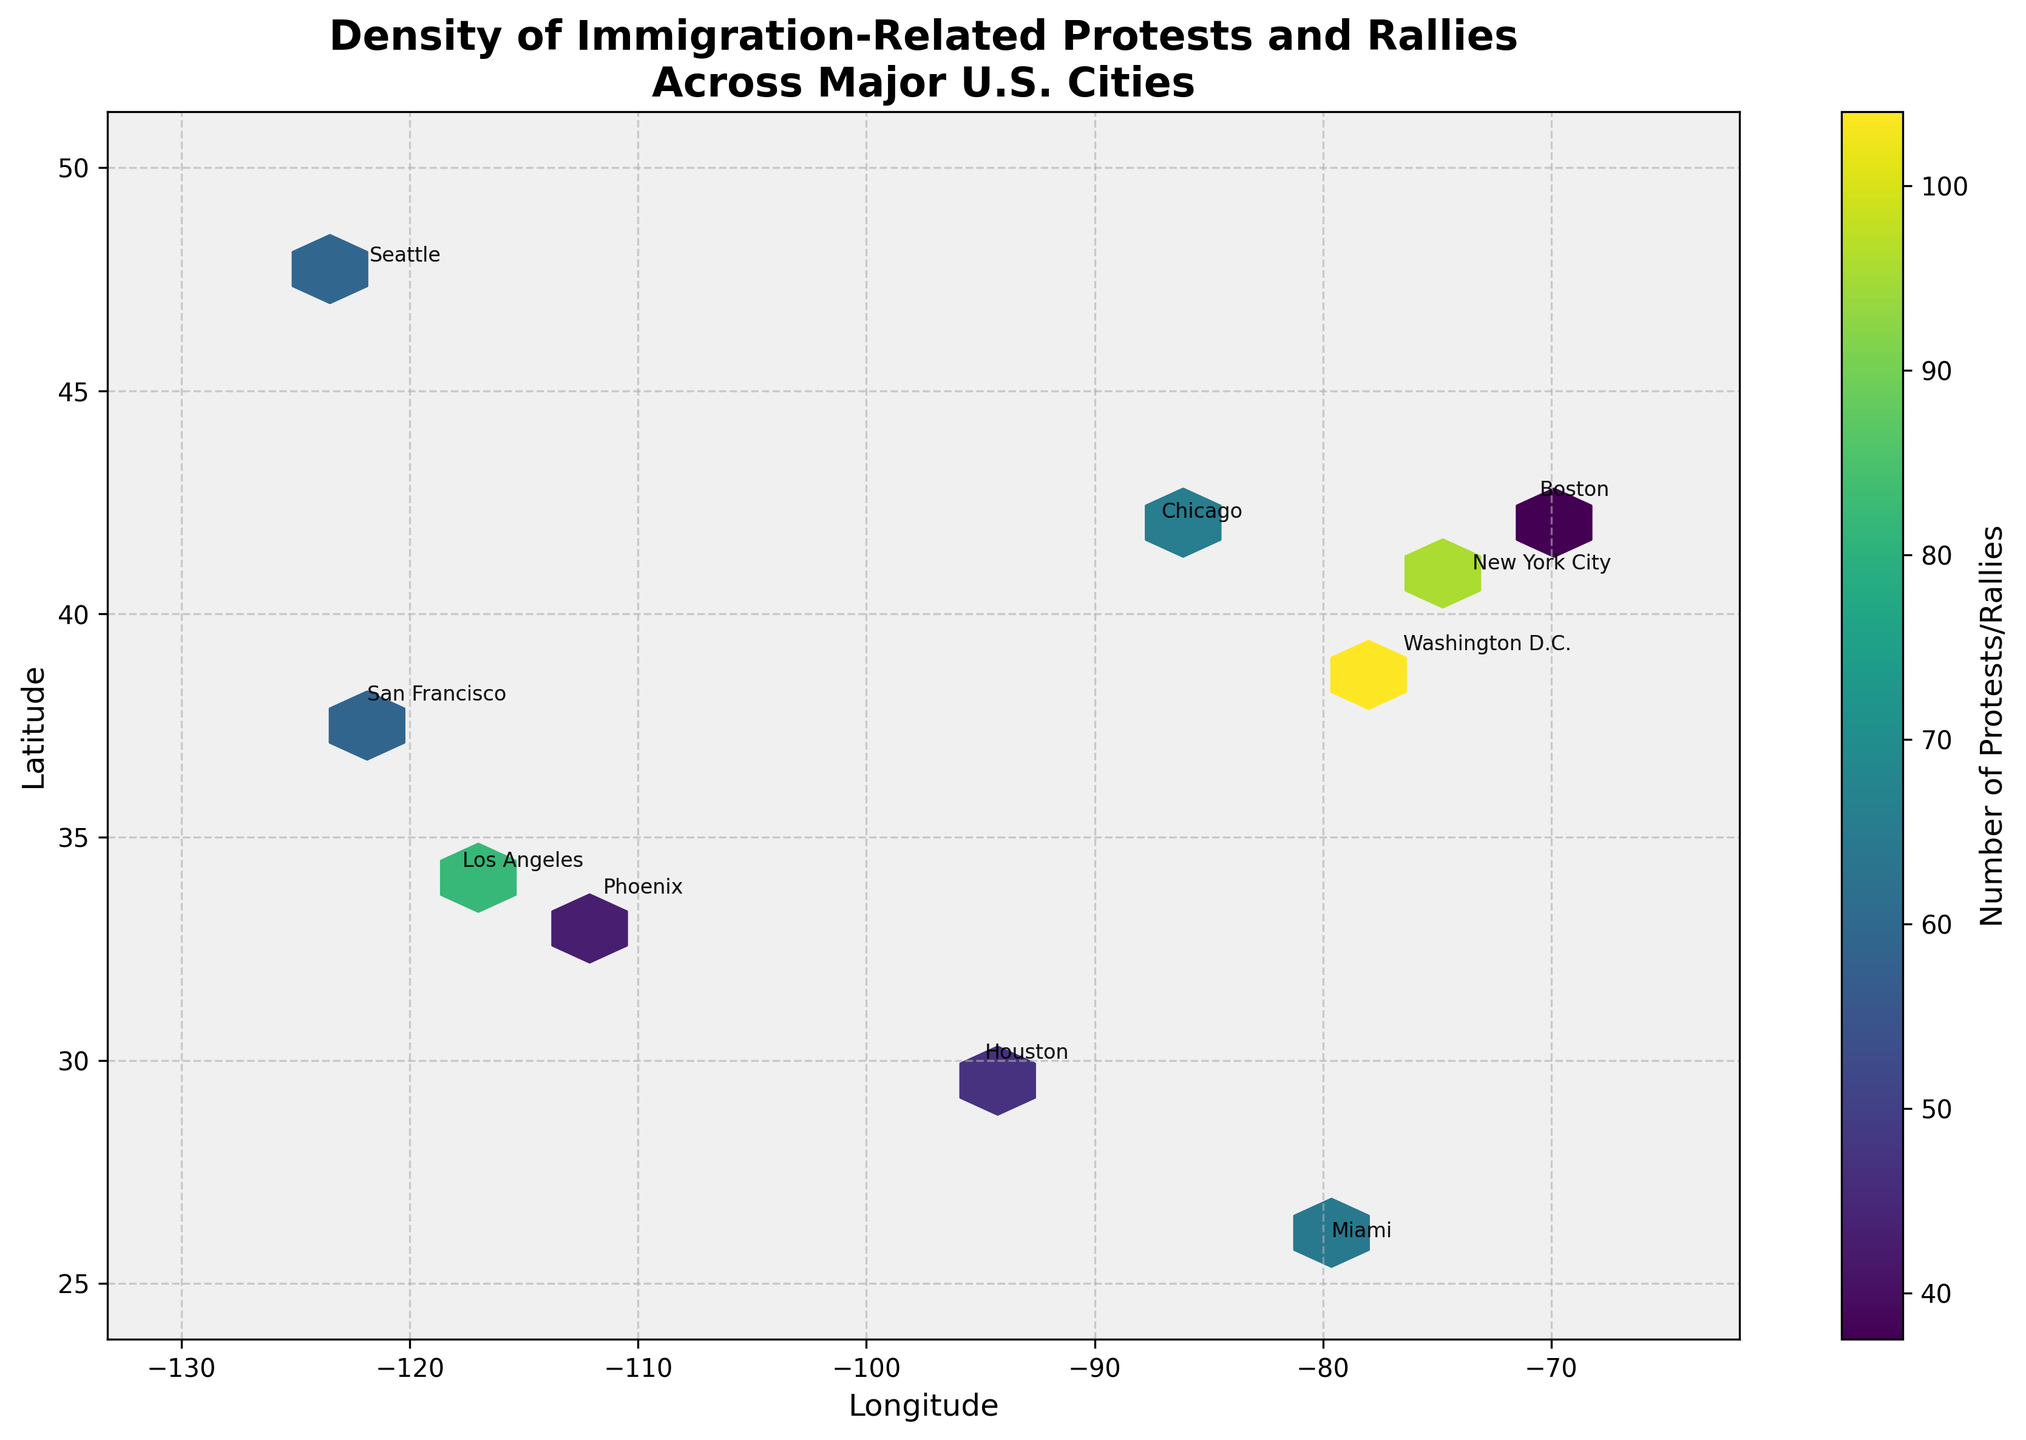What is the title of the figure? The title is located at the top of the figure and provides an overview of what the plot represents.
Answer: Density of Immigration-Related Protests and Rallies Across Major U.S. Cities Which city had the highest number of protests or rallies in 2018? By looking at the color bar and correlating it with the hexagons' color, we can identify that the darkest hexagon, representing the highest number of protests, marks Washington D.C.
Answer: Washington D.C How are the longitude and latitude represented in the plot? Longitude is represented on the x-axis, ranging approximately from -130 to -65. Latitude is represented on the y-axis, ranging approximately from 25 to 50.
Answer: Longitude on x-axis, Latitude on y-axis Which city had a significant increase in protests from 2017 to 2018? By comparing the respective hexagons for the two years, San Francisco shows a notable increase in color intensity from 2017 (45 protests) to 2018 (73 protests).
Answer: San Francisco What is the total number of protests for Los Angeles across 2017 and 2018? Summing the values for both years: 78 (2017) + 86 (2018) = 164
Answer: 164 Were there more protests in New York City or Chicago in 2018? Checking the hexagons' color based on the value scale, New York City had 102 (much higher value) compared to Chicago's 69 in 2018.
Answer: New York City How many data points are represented in the plot? By counting the number of annotated cities, which corresponds to the number of data points in the plot, we find there are 19.
Answer: 19 Which cities are marked on the plot but had fewer than 50 protests in 2018? By checking the hexagons with light colors and their annotations, Phoenix (49), Boston (44), and Houston (53 close to 50) are cities below or near this threshold.
Answer: Phoenix, Boston, Houston What does the color bar next to the hexbin plot represent? The color bar provides a legend indicating the number of protests or rallies, with lighter colors representing fewer protests and darker colors representing more protests.
Answer: Number of Protests/Rallies 